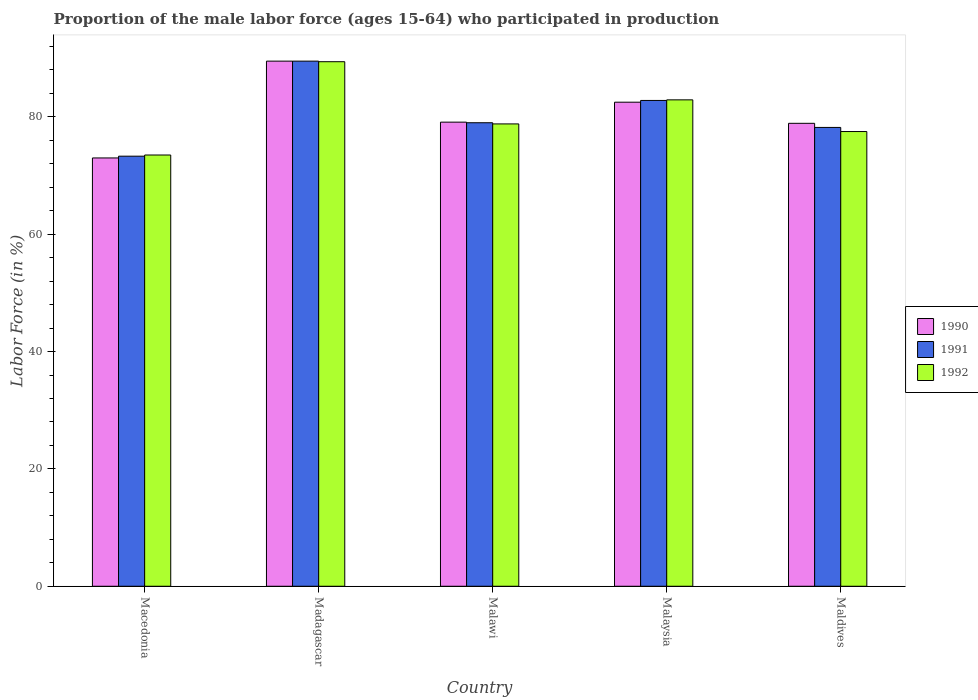How many different coloured bars are there?
Make the answer very short. 3. Are the number of bars on each tick of the X-axis equal?
Ensure brevity in your answer.  Yes. What is the label of the 4th group of bars from the left?
Keep it short and to the point. Malaysia. In how many cases, is the number of bars for a given country not equal to the number of legend labels?
Offer a terse response. 0. What is the proportion of the male labor force who participated in production in 1992 in Malaysia?
Keep it short and to the point. 82.9. Across all countries, what is the maximum proportion of the male labor force who participated in production in 1990?
Your answer should be very brief. 89.5. Across all countries, what is the minimum proportion of the male labor force who participated in production in 1992?
Offer a very short reply. 73.5. In which country was the proportion of the male labor force who participated in production in 1990 maximum?
Your answer should be compact. Madagascar. In which country was the proportion of the male labor force who participated in production in 1990 minimum?
Your answer should be compact. Macedonia. What is the total proportion of the male labor force who participated in production in 1992 in the graph?
Offer a very short reply. 402.1. What is the difference between the proportion of the male labor force who participated in production in 1991 in Madagascar and that in Maldives?
Provide a succinct answer. 11.3. What is the difference between the proportion of the male labor force who participated in production in 1990 in Macedonia and the proportion of the male labor force who participated in production in 1991 in Malaysia?
Offer a terse response. -9.8. What is the average proportion of the male labor force who participated in production in 1990 per country?
Your response must be concise. 80.6. What is the difference between the proportion of the male labor force who participated in production of/in 1991 and proportion of the male labor force who participated in production of/in 1992 in Madagascar?
Give a very brief answer. 0.1. In how many countries, is the proportion of the male labor force who participated in production in 1991 greater than 68 %?
Your answer should be very brief. 5. What is the ratio of the proportion of the male labor force who participated in production in 1992 in Madagascar to that in Malawi?
Your answer should be compact. 1.13. What is the difference between the highest and the second highest proportion of the male labor force who participated in production in 1990?
Your answer should be very brief. 7. Is the sum of the proportion of the male labor force who participated in production in 1992 in Macedonia and Malawi greater than the maximum proportion of the male labor force who participated in production in 1990 across all countries?
Offer a very short reply. Yes. What does the 2nd bar from the right in Malawi represents?
Provide a short and direct response. 1991. How many bars are there?
Give a very brief answer. 15. Are all the bars in the graph horizontal?
Offer a very short reply. No. How many countries are there in the graph?
Ensure brevity in your answer.  5. Does the graph contain any zero values?
Your response must be concise. No. Does the graph contain grids?
Give a very brief answer. No. How many legend labels are there?
Provide a short and direct response. 3. What is the title of the graph?
Your answer should be very brief. Proportion of the male labor force (ages 15-64) who participated in production. What is the label or title of the X-axis?
Ensure brevity in your answer.  Country. What is the Labor Force (in %) of 1991 in Macedonia?
Provide a short and direct response. 73.3. What is the Labor Force (in %) in 1992 in Macedonia?
Your answer should be very brief. 73.5. What is the Labor Force (in %) of 1990 in Madagascar?
Your answer should be very brief. 89.5. What is the Labor Force (in %) in 1991 in Madagascar?
Your answer should be compact. 89.5. What is the Labor Force (in %) in 1992 in Madagascar?
Your answer should be compact. 89.4. What is the Labor Force (in %) of 1990 in Malawi?
Provide a succinct answer. 79.1. What is the Labor Force (in %) of 1991 in Malawi?
Provide a succinct answer. 79. What is the Labor Force (in %) in 1992 in Malawi?
Provide a succinct answer. 78.8. What is the Labor Force (in %) in 1990 in Malaysia?
Make the answer very short. 82.5. What is the Labor Force (in %) in 1991 in Malaysia?
Keep it short and to the point. 82.8. What is the Labor Force (in %) in 1992 in Malaysia?
Offer a very short reply. 82.9. What is the Labor Force (in %) in 1990 in Maldives?
Keep it short and to the point. 78.9. What is the Labor Force (in %) of 1991 in Maldives?
Give a very brief answer. 78.2. What is the Labor Force (in %) of 1992 in Maldives?
Give a very brief answer. 77.5. Across all countries, what is the maximum Labor Force (in %) of 1990?
Keep it short and to the point. 89.5. Across all countries, what is the maximum Labor Force (in %) of 1991?
Your answer should be very brief. 89.5. Across all countries, what is the maximum Labor Force (in %) in 1992?
Give a very brief answer. 89.4. Across all countries, what is the minimum Labor Force (in %) in 1991?
Your answer should be compact. 73.3. Across all countries, what is the minimum Labor Force (in %) in 1992?
Provide a succinct answer. 73.5. What is the total Labor Force (in %) of 1990 in the graph?
Keep it short and to the point. 403. What is the total Labor Force (in %) of 1991 in the graph?
Offer a very short reply. 402.8. What is the total Labor Force (in %) in 1992 in the graph?
Provide a short and direct response. 402.1. What is the difference between the Labor Force (in %) in 1990 in Macedonia and that in Madagascar?
Provide a short and direct response. -16.5. What is the difference between the Labor Force (in %) in 1991 in Macedonia and that in Madagascar?
Offer a terse response. -16.2. What is the difference between the Labor Force (in %) of 1992 in Macedonia and that in Madagascar?
Offer a terse response. -15.9. What is the difference between the Labor Force (in %) of 1990 in Macedonia and that in Maldives?
Provide a short and direct response. -5.9. What is the difference between the Labor Force (in %) of 1992 in Macedonia and that in Maldives?
Offer a terse response. -4. What is the difference between the Labor Force (in %) in 1991 in Madagascar and that in Malawi?
Ensure brevity in your answer.  10.5. What is the difference between the Labor Force (in %) in 1992 in Madagascar and that in Malawi?
Your answer should be very brief. 10.6. What is the difference between the Labor Force (in %) of 1992 in Madagascar and that in Malaysia?
Your answer should be compact. 6.5. What is the difference between the Labor Force (in %) of 1990 in Malawi and that in Malaysia?
Provide a succinct answer. -3.4. What is the difference between the Labor Force (in %) in 1992 in Malawi and that in Malaysia?
Your answer should be compact. -4.1. What is the difference between the Labor Force (in %) in 1990 in Malawi and that in Maldives?
Ensure brevity in your answer.  0.2. What is the difference between the Labor Force (in %) of 1991 in Malawi and that in Maldives?
Provide a short and direct response. 0.8. What is the difference between the Labor Force (in %) of 1992 in Malawi and that in Maldives?
Make the answer very short. 1.3. What is the difference between the Labor Force (in %) in 1991 in Malaysia and that in Maldives?
Offer a very short reply. 4.6. What is the difference between the Labor Force (in %) in 1990 in Macedonia and the Labor Force (in %) in 1991 in Madagascar?
Your answer should be compact. -16.5. What is the difference between the Labor Force (in %) of 1990 in Macedonia and the Labor Force (in %) of 1992 in Madagascar?
Make the answer very short. -16.4. What is the difference between the Labor Force (in %) in 1991 in Macedonia and the Labor Force (in %) in 1992 in Madagascar?
Keep it short and to the point. -16.1. What is the difference between the Labor Force (in %) of 1990 in Macedonia and the Labor Force (in %) of 1991 in Malawi?
Your answer should be compact. -6. What is the difference between the Labor Force (in %) of 1991 in Macedonia and the Labor Force (in %) of 1992 in Malawi?
Your answer should be compact. -5.5. What is the difference between the Labor Force (in %) in 1990 in Macedonia and the Labor Force (in %) in 1992 in Malaysia?
Make the answer very short. -9.9. What is the difference between the Labor Force (in %) in 1990 in Macedonia and the Labor Force (in %) in 1991 in Maldives?
Offer a terse response. -5.2. What is the difference between the Labor Force (in %) in 1990 in Macedonia and the Labor Force (in %) in 1992 in Maldives?
Provide a succinct answer. -4.5. What is the difference between the Labor Force (in %) in 1990 in Madagascar and the Labor Force (in %) in 1991 in Malawi?
Your answer should be very brief. 10.5. What is the difference between the Labor Force (in %) of 1990 in Madagascar and the Labor Force (in %) of 1992 in Malawi?
Give a very brief answer. 10.7. What is the difference between the Labor Force (in %) in 1990 in Madagascar and the Labor Force (in %) in 1991 in Malaysia?
Your answer should be very brief. 6.7. What is the difference between the Labor Force (in %) of 1990 in Madagascar and the Labor Force (in %) of 1992 in Malaysia?
Ensure brevity in your answer.  6.6. What is the difference between the Labor Force (in %) in 1991 in Madagascar and the Labor Force (in %) in 1992 in Malaysia?
Keep it short and to the point. 6.6. What is the difference between the Labor Force (in %) in 1990 in Madagascar and the Labor Force (in %) in 1991 in Maldives?
Your answer should be very brief. 11.3. What is the difference between the Labor Force (in %) in 1990 in Madagascar and the Labor Force (in %) in 1992 in Maldives?
Offer a very short reply. 12. What is the difference between the Labor Force (in %) of 1991 in Madagascar and the Labor Force (in %) of 1992 in Maldives?
Offer a terse response. 12. What is the difference between the Labor Force (in %) in 1990 in Malawi and the Labor Force (in %) in 1992 in Malaysia?
Ensure brevity in your answer.  -3.8. What is the difference between the Labor Force (in %) of 1990 in Malawi and the Labor Force (in %) of 1991 in Maldives?
Make the answer very short. 0.9. What is the difference between the Labor Force (in %) in 1990 in Malawi and the Labor Force (in %) in 1992 in Maldives?
Provide a short and direct response. 1.6. What is the difference between the Labor Force (in %) of 1990 in Malaysia and the Labor Force (in %) of 1991 in Maldives?
Make the answer very short. 4.3. What is the difference between the Labor Force (in %) in 1990 in Malaysia and the Labor Force (in %) in 1992 in Maldives?
Your answer should be compact. 5. What is the difference between the Labor Force (in %) in 1991 in Malaysia and the Labor Force (in %) in 1992 in Maldives?
Make the answer very short. 5.3. What is the average Labor Force (in %) of 1990 per country?
Provide a succinct answer. 80.6. What is the average Labor Force (in %) of 1991 per country?
Make the answer very short. 80.56. What is the average Labor Force (in %) of 1992 per country?
Make the answer very short. 80.42. What is the difference between the Labor Force (in %) of 1990 and Labor Force (in %) of 1991 in Macedonia?
Your answer should be compact. -0.3. What is the difference between the Labor Force (in %) in 1991 and Labor Force (in %) in 1992 in Macedonia?
Offer a very short reply. -0.2. What is the difference between the Labor Force (in %) of 1990 and Labor Force (in %) of 1991 in Madagascar?
Ensure brevity in your answer.  0. What is the difference between the Labor Force (in %) of 1990 and Labor Force (in %) of 1992 in Madagascar?
Offer a terse response. 0.1. What is the difference between the Labor Force (in %) of 1991 and Labor Force (in %) of 1992 in Madagascar?
Ensure brevity in your answer.  0.1. What is the difference between the Labor Force (in %) in 1991 and Labor Force (in %) in 1992 in Malawi?
Ensure brevity in your answer.  0.2. What is the difference between the Labor Force (in %) of 1990 and Labor Force (in %) of 1992 in Malaysia?
Make the answer very short. -0.4. What is the difference between the Labor Force (in %) in 1991 and Labor Force (in %) in 1992 in Malaysia?
Give a very brief answer. -0.1. What is the ratio of the Labor Force (in %) in 1990 in Macedonia to that in Madagascar?
Offer a terse response. 0.82. What is the ratio of the Labor Force (in %) of 1991 in Macedonia to that in Madagascar?
Make the answer very short. 0.82. What is the ratio of the Labor Force (in %) of 1992 in Macedonia to that in Madagascar?
Your response must be concise. 0.82. What is the ratio of the Labor Force (in %) of 1990 in Macedonia to that in Malawi?
Your answer should be compact. 0.92. What is the ratio of the Labor Force (in %) of 1991 in Macedonia to that in Malawi?
Keep it short and to the point. 0.93. What is the ratio of the Labor Force (in %) of 1992 in Macedonia to that in Malawi?
Give a very brief answer. 0.93. What is the ratio of the Labor Force (in %) of 1990 in Macedonia to that in Malaysia?
Give a very brief answer. 0.88. What is the ratio of the Labor Force (in %) in 1991 in Macedonia to that in Malaysia?
Provide a succinct answer. 0.89. What is the ratio of the Labor Force (in %) of 1992 in Macedonia to that in Malaysia?
Your response must be concise. 0.89. What is the ratio of the Labor Force (in %) of 1990 in Macedonia to that in Maldives?
Your answer should be compact. 0.93. What is the ratio of the Labor Force (in %) of 1991 in Macedonia to that in Maldives?
Provide a short and direct response. 0.94. What is the ratio of the Labor Force (in %) in 1992 in Macedonia to that in Maldives?
Offer a terse response. 0.95. What is the ratio of the Labor Force (in %) of 1990 in Madagascar to that in Malawi?
Your answer should be compact. 1.13. What is the ratio of the Labor Force (in %) in 1991 in Madagascar to that in Malawi?
Make the answer very short. 1.13. What is the ratio of the Labor Force (in %) of 1992 in Madagascar to that in Malawi?
Provide a short and direct response. 1.13. What is the ratio of the Labor Force (in %) of 1990 in Madagascar to that in Malaysia?
Ensure brevity in your answer.  1.08. What is the ratio of the Labor Force (in %) of 1991 in Madagascar to that in Malaysia?
Provide a short and direct response. 1.08. What is the ratio of the Labor Force (in %) in 1992 in Madagascar to that in Malaysia?
Ensure brevity in your answer.  1.08. What is the ratio of the Labor Force (in %) in 1990 in Madagascar to that in Maldives?
Your answer should be compact. 1.13. What is the ratio of the Labor Force (in %) of 1991 in Madagascar to that in Maldives?
Your answer should be compact. 1.14. What is the ratio of the Labor Force (in %) in 1992 in Madagascar to that in Maldives?
Offer a very short reply. 1.15. What is the ratio of the Labor Force (in %) of 1990 in Malawi to that in Malaysia?
Offer a terse response. 0.96. What is the ratio of the Labor Force (in %) of 1991 in Malawi to that in Malaysia?
Your response must be concise. 0.95. What is the ratio of the Labor Force (in %) of 1992 in Malawi to that in Malaysia?
Offer a terse response. 0.95. What is the ratio of the Labor Force (in %) in 1990 in Malawi to that in Maldives?
Your response must be concise. 1. What is the ratio of the Labor Force (in %) of 1991 in Malawi to that in Maldives?
Give a very brief answer. 1.01. What is the ratio of the Labor Force (in %) in 1992 in Malawi to that in Maldives?
Provide a succinct answer. 1.02. What is the ratio of the Labor Force (in %) of 1990 in Malaysia to that in Maldives?
Keep it short and to the point. 1.05. What is the ratio of the Labor Force (in %) of 1991 in Malaysia to that in Maldives?
Give a very brief answer. 1.06. What is the ratio of the Labor Force (in %) in 1992 in Malaysia to that in Maldives?
Keep it short and to the point. 1.07. What is the difference between the highest and the second highest Labor Force (in %) in 1990?
Offer a very short reply. 7. What is the difference between the highest and the second highest Labor Force (in %) of 1991?
Ensure brevity in your answer.  6.7. What is the difference between the highest and the lowest Labor Force (in %) in 1990?
Ensure brevity in your answer.  16.5. What is the difference between the highest and the lowest Labor Force (in %) in 1991?
Offer a very short reply. 16.2. What is the difference between the highest and the lowest Labor Force (in %) of 1992?
Provide a short and direct response. 15.9. 